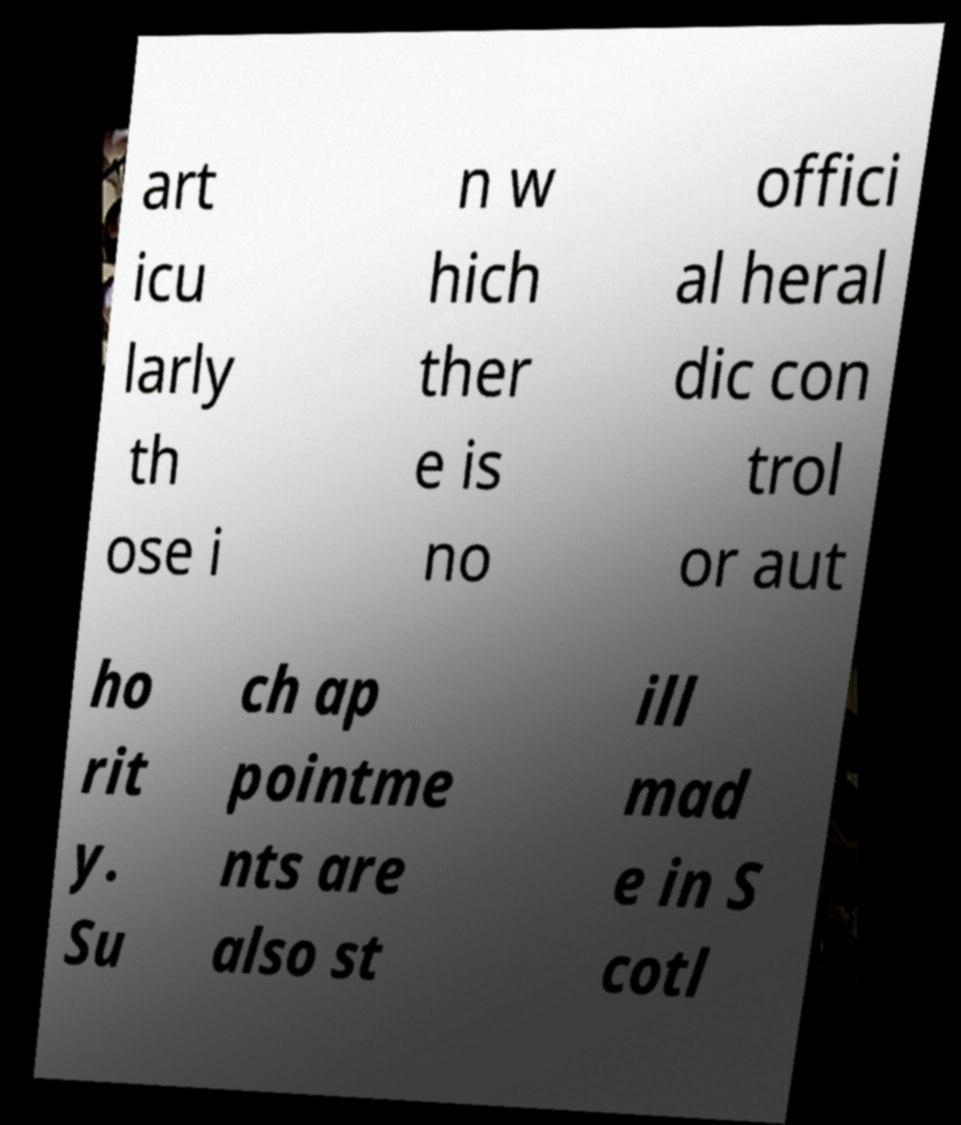There's text embedded in this image that I need extracted. Can you transcribe it verbatim? art icu larly th ose i n w hich ther e is no offici al heral dic con trol or aut ho rit y. Su ch ap pointme nts are also st ill mad e in S cotl 